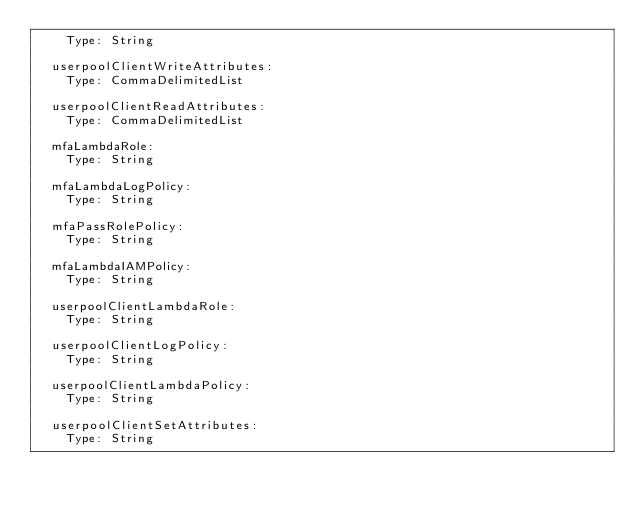Convert code to text. <code><loc_0><loc_0><loc_500><loc_500><_YAML_>    Type: String
                  
  userpoolClientWriteAttributes:
    Type: CommaDelimitedList
            
  userpoolClientReadAttributes:
    Type: CommaDelimitedList
      
  mfaLambdaRole:
    Type: String
            
  mfaLambdaLogPolicy:
    Type: String
            
  mfaPassRolePolicy:
    Type: String
            
  mfaLambdaIAMPolicy:
    Type: String
            
  userpoolClientLambdaRole:
    Type: String
            
  userpoolClientLogPolicy:
    Type: String
            
  userpoolClientLambdaPolicy:
    Type: String
              
  userpoolClientSetAttributes:
    Type: String
          </code> 